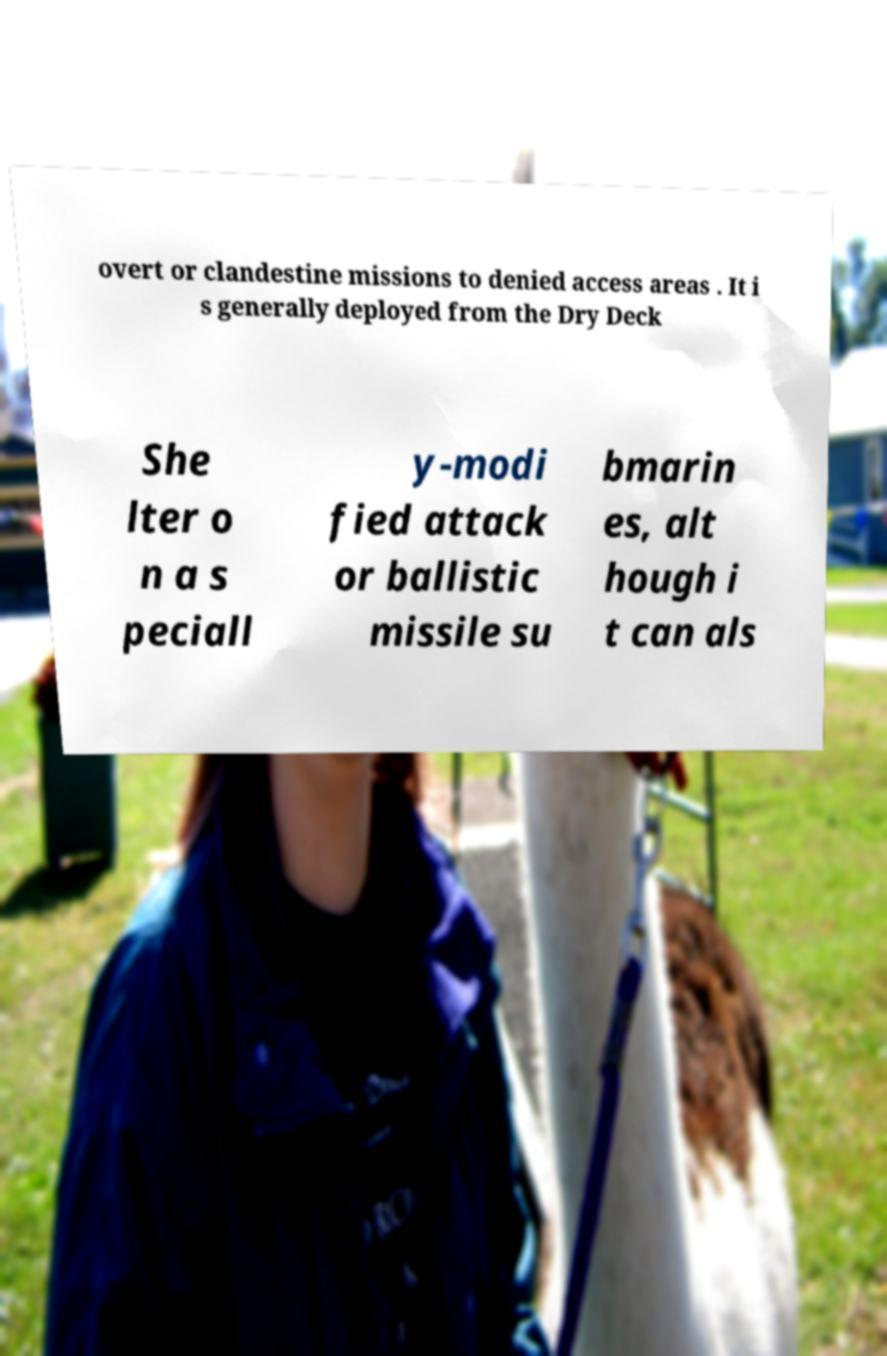Can you accurately transcribe the text from the provided image for me? overt or clandestine missions to denied access areas . It i s generally deployed from the Dry Deck She lter o n a s peciall y-modi fied attack or ballistic missile su bmarin es, alt hough i t can als 